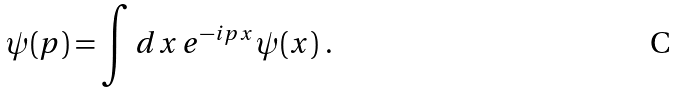<formula> <loc_0><loc_0><loc_500><loc_500>\psi ( p ) = \int d x \, e ^ { - i p x } \psi ( x ) \ .</formula> 